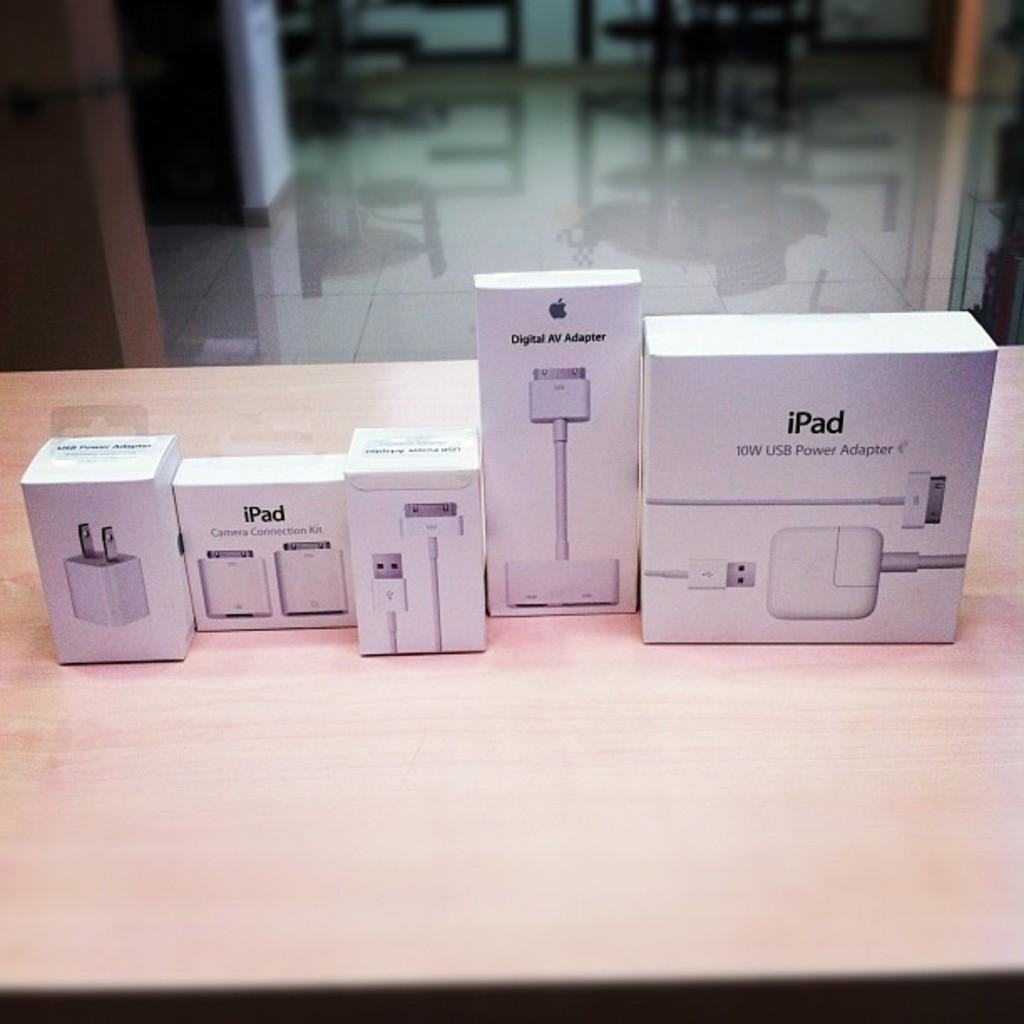Provide a one-sentence caption for the provided image. some boxes of iPad accessories for your iPad itself. 